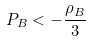<formula> <loc_0><loc_0><loc_500><loc_500>P _ { B } < - \frac { \rho _ { B } } { 3 }</formula> 